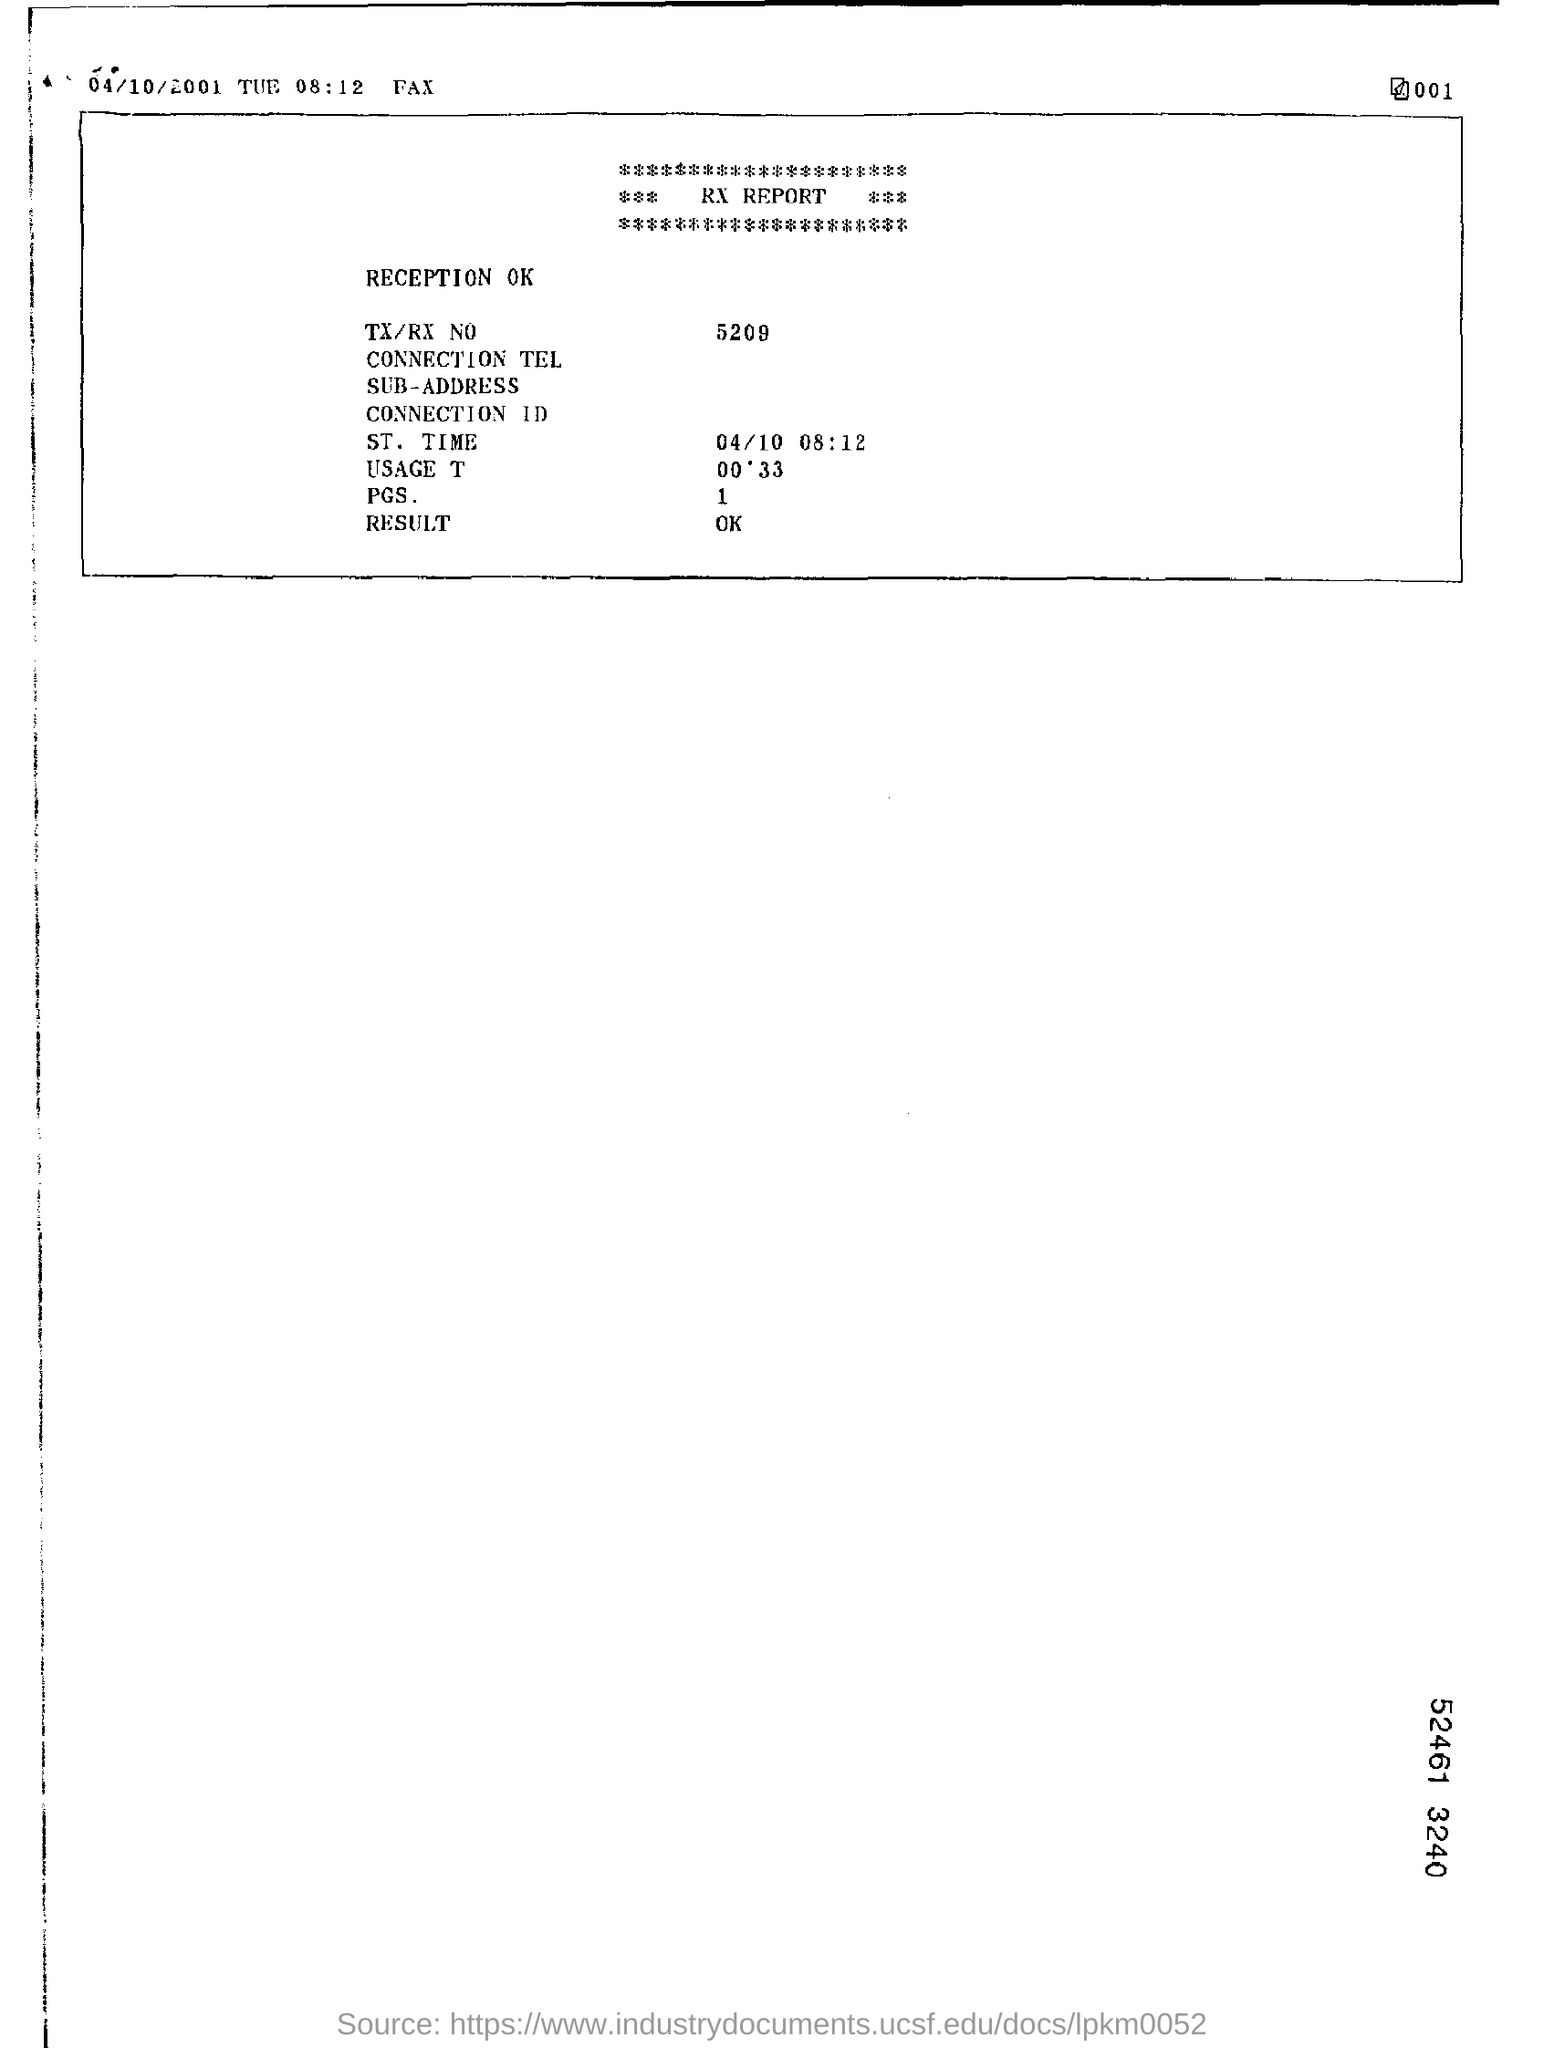Indicate a few pertinent items in this graphic. The TX/RX number given in the RX report is 5209. What is the ST mentioned in the RX report? It is 04/10 at 08:12. 